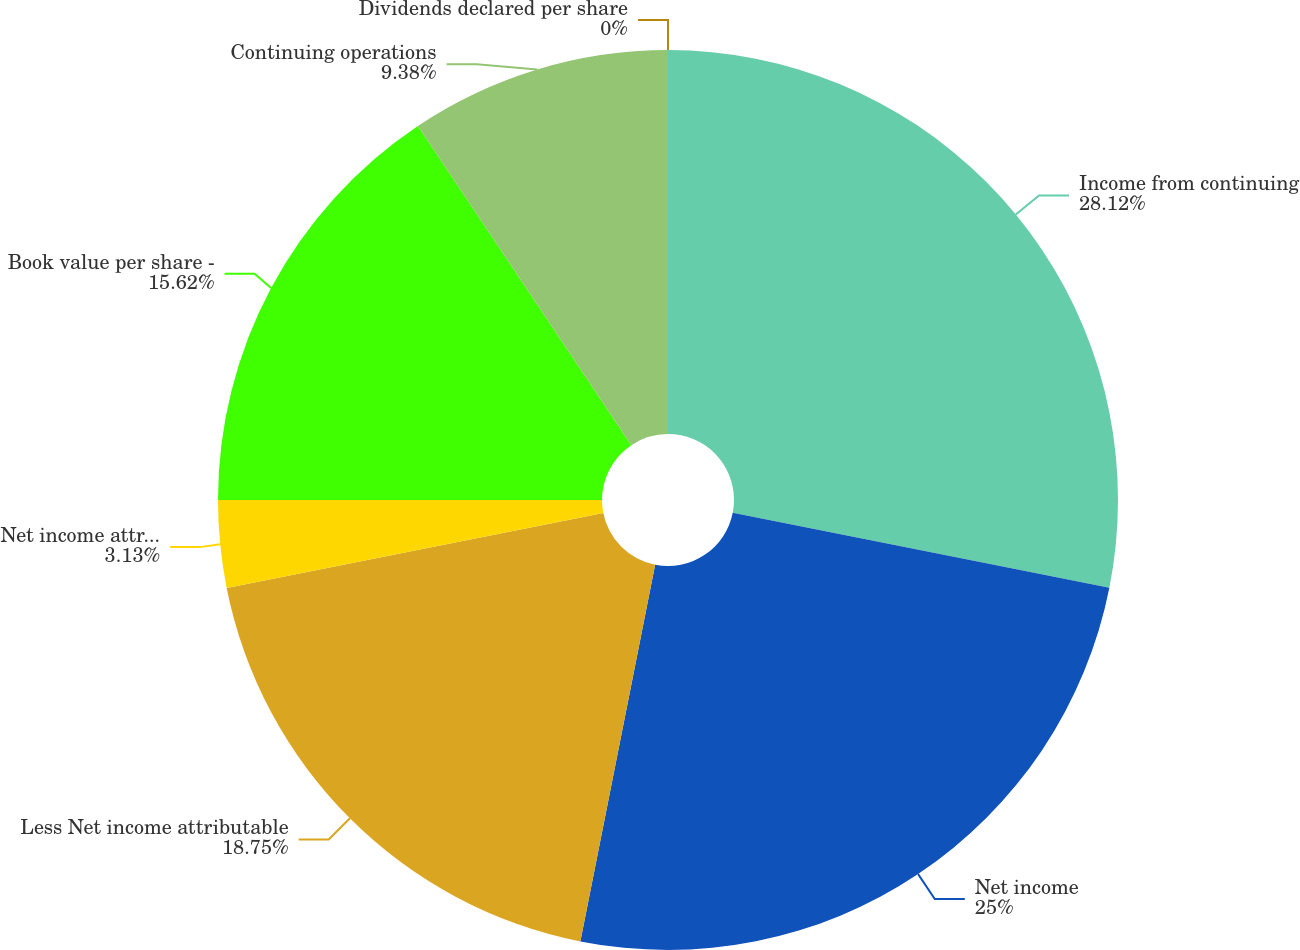Convert chart to OTSL. <chart><loc_0><loc_0><loc_500><loc_500><pie_chart><fcel>Income from continuing<fcel>Net income<fcel>Less Net income attributable<fcel>Net income attributable to<fcel>Book value per share -<fcel>Continuing operations<fcel>Dividends declared per share<nl><fcel>28.12%<fcel>25.0%<fcel>18.75%<fcel>3.13%<fcel>15.62%<fcel>9.38%<fcel>0.0%<nl></chart> 